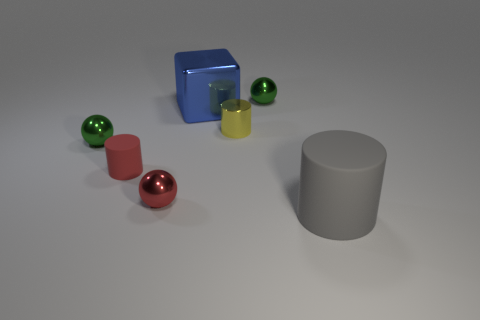There is a green object that is left of the shiny thing behind the large blue cube; how big is it?
Provide a succinct answer. Small. Is the color of the thing that is to the left of the red rubber thing the same as the shiny thing that is to the right of the tiny yellow shiny cylinder?
Provide a short and direct response. Yes. The cylinder that is on the right side of the red metallic ball and on the left side of the big gray cylinder is what color?
Give a very brief answer. Yellow. What number of other things are there of the same shape as the big gray thing?
Ensure brevity in your answer.  2. What is the color of the thing that is the same size as the gray cylinder?
Provide a short and direct response. Blue. There is a small cylinder on the left side of the metallic cylinder; what is its color?
Offer a very short reply. Red. There is a large object that is behind the gray thing; are there any big blue shiny things in front of it?
Provide a succinct answer. No. There is a blue metallic thing; does it have the same shape as the tiny green metal thing that is left of the blue metallic block?
Offer a terse response. No. How big is the thing that is behind the red matte cylinder and on the right side of the yellow metal object?
Your answer should be compact. Small. Are there any large objects that have the same material as the red cylinder?
Offer a terse response. Yes. 